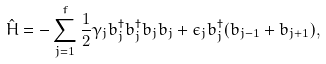Convert formula to latex. <formula><loc_0><loc_0><loc_500><loc_500>\hat { H } = - \sum _ { j = 1 } ^ { f } \frac { 1 } { 2 } \gamma _ { j } b _ { j } ^ { \dag } b _ { j } ^ { \dag } b _ { j } b _ { j } + \epsilon _ { j } b _ { j } ^ { \dag } ( b _ { j - 1 } + b _ { j + 1 } ) ,</formula> 